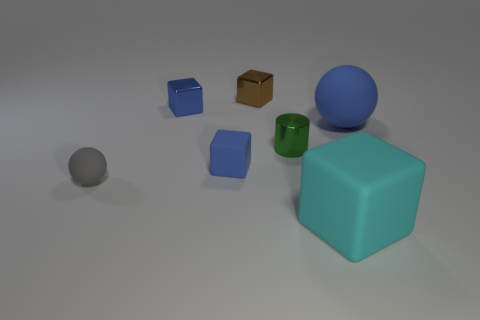Is the small brown thing the same shape as the green object?
Ensure brevity in your answer.  No. Is there anything else that has the same color as the small rubber sphere?
Offer a very short reply. No. The other tiny matte object that is the same shape as the brown thing is what color?
Keep it short and to the point. Blue. Are there more tiny green objects that are left of the tiny rubber cube than large purple metal objects?
Offer a terse response. No. The large rubber object left of the large sphere is what color?
Your answer should be very brief. Cyan. Is the gray thing the same size as the brown metal cube?
Your answer should be very brief. Yes. What size is the blue metallic cube?
Your answer should be very brief. Small. What shape is the metal thing that is the same color as the large sphere?
Provide a succinct answer. Cube. Is the number of small gray rubber things greater than the number of brown metallic cylinders?
Give a very brief answer. Yes. The matte ball on the right side of the large object that is left of the large matte object behind the tiny gray rubber sphere is what color?
Provide a short and direct response. Blue. 